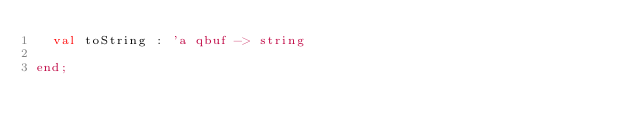<code> <loc_0><loc_0><loc_500><loc_500><_SML_>  val toString : 'a qbuf -> string

end;

</code> 